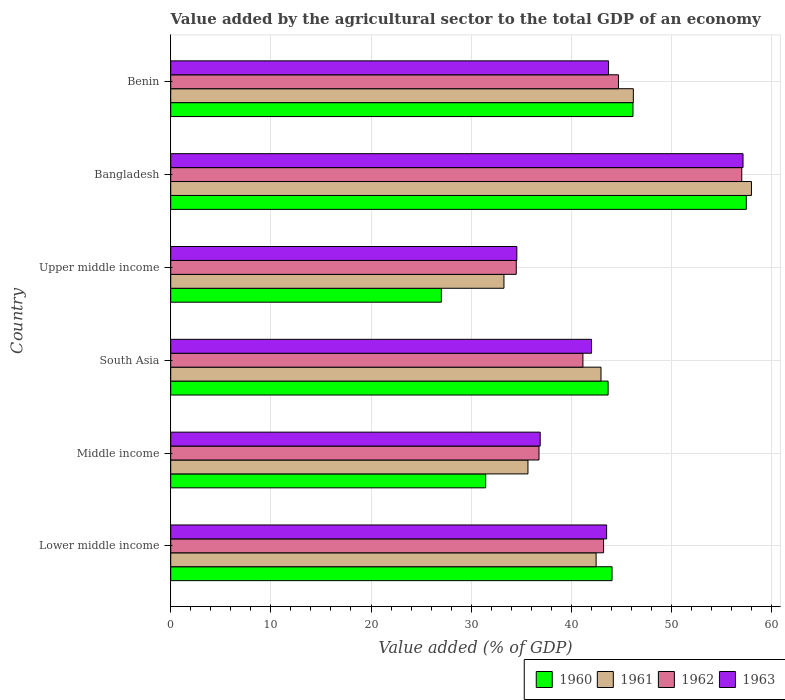How many different coloured bars are there?
Provide a short and direct response. 4. Are the number of bars per tick equal to the number of legend labels?
Ensure brevity in your answer.  Yes. How many bars are there on the 1st tick from the top?
Give a very brief answer. 4. How many bars are there on the 5th tick from the bottom?
Ensure brevity in your answer.  4. What is the label of the 3rd group of bars from the top?
Your answer should be very brief. Upper middle income. What is the value added by the agricultural sector to the total GDP in 1961 in Upper middle income?
Ensure brevity in your answer.  33.27. Across all countries, what is the maximum value added by the agricultural sector to the total GDP in 1960?
Offer a terse response. 57.47. Across all countries, what is the minimum value added by the agricultural sector to the total GDP in 1960?
Provide a short and direct response. 27.02. In which country was the value added by the agricultural sector to the total GDP in 1961 minimum?
Provide a short and direct response. Upper middle income. What is the total value added by the agricultural sector to the total GDP in 1960 in the graph?
Give a very brief answer. 249.85. What is the difference between the value added by the agricultural sector to the total GDP in 1961 in South Asia and that in Upper middle income?
Make the answer very short. 9.69. What is the difference between the value added by the agricultural sector to the total GDP in 1963 in Middle income and the value added by the agricultural sector to the total GDP in 1962 in Upper middle income?
Your answer should be very brief. 2.39. What is the average value added by the agricultural sector to the total GDP in 1963 per country?
Offer a terse response. 42.98. What is the difference between the value added by the agricultural sector to the total GDP in 1960 and value added by the agricultural sector to the total GDP in 1961 in Lower middle income?
Ensure brevity in your answer.  1.59. In how many countries, is the value added by the agricultural sector to the total GDP in 1962 greater than 58 %?
Make the answer very short. 0. What is the ratio of the value added by the agricultural sector to the total GDP in 1961 in South Asia to that in Upper middle income?
Give a very brief answer. 1.29. Is the value added by the agricultural sector to the total GDP in 1963 in Lower middle income less than that in Middle income?
Keep it short and to the point. No. Is the difference between the value added by the agricultural sector to the total GDP in 1960 in Lower middle income and Middle income greater than the difference between the value added by the agricultural sector to the total GDP in 1961 in Lower middle income and Middle income?
Your answer should be compact. Yes. What is the difference between the highest and the second highest value added by the agricultural sector to the total GDP in 1960?
Make the answer very short. 11.32. What is the difference between the highest and the lowest value added by the agricultural sector to the total GDP in 1960?
Your answer should be very brief. 30.45. In how many countries, is the value added by the agricultural sector to the total GDP in 1963 greater than the average value added by the agricultural sector to the total GDP in 1963 taken over all countries?
Provide a succinct answer. 3. Is the sum of the value added by the agricultural sector to the total GDP in 1960 in Bangladesh and Middle income greater than the maximum value added by the agricultural sector to the total GDP in 1962 across all countries?
Your answer should be compact. Yes. Is it the case that in every country, the sum of the value added by the agricultural sector to the total GDP in 1961 and value added by the agricultural sector to the total GDP in 1962 is greater than the sum of value added by the agricultural sector to the total GDP in 1963 and value added by the agricultural sector to the total GDP in 1960?
Make the answer very short. No. How many bars are there?
Your response must be concise. 24. Are all the bars in the graph horizontal?
Offer a terse response. Yes. Are the values on the major ticks of X-axis written in scientific E-notation?
Ensure brevity in your answer.  No. How many legend labels are there?
Give a very brief answer. 4. How are the legend labels stacked?
Offer a very short reply. Horizontal. What is the title of the graph?
Your answer should be compact. Value added by the agricultural sector to the total GDP of an economy. Does "1975" appear as one of the legend labels in the graph?
Provide a succinct answer. No. What is the label or title of the X-axis?
Give a very brief answer. Value added (% of GDP). What is the Value added (% of GDP) in 1960 in Lower middle income?
Your answer should be compact. 44.07. What is the Value added (% of GDP) of 1961 in Lower middle income?
Keep it short and to the point. 42.48. What is the Value added (% of GDP) in 1962 in Lower middle income?
Provide a short and direct response. 43.22. What is the Value added (% of GDP) in 1963 in Lower middle income?
Keep it short and to the point. 43.53. What is the Value added (% of GDP) of 1960 in Middle income?
Keep it short and to the point. 31.45. What is the Value added (% of GDP) in 1961 in Middle income?
Your answer should be compact. 35.67. What is the Value added (% of GDP) in 1962 in Middle income?
Provide a succinct answer. 36.77. What is the Value added (% of GDP) of 1963 in Middle income?
Your answer should be compact. 36.89. What is the Value added (% of GDP) of 1960 in South Asia?
Ensure brevity in your answer.  43.68. What is the Value added (% of GDP) in 1961 in South Asia?
Give a very brief answer. 42.96. What is the Value added (% of GDP) of 1962 in South Asia?
Your response must be concise. 41.16. What is the Value added (% of GDP) of 1963 in South Asia?
Your answer should be very brief. 42.02. What is the Value added (% of GDP) in 1960 in Upper middle income?
Your answer should be compact. 27.02. What is the Value added (% of GDP) of 1961 in Upper middle income?
Ensure brevity in your answer.  33.27. What is the Value added (% of GDP) of 1962 in Upper middle income?
Offer a very short reply. 34.5. What is the Value added (% of GDP) of 1963 in Upper middle income?
Offer a terse response. 34.56. What is the Value added (% of GDP) of 1960 in Bangladesh?
Offer a terse response. 57.47. What is the Value added (% of GDP) in 1961 in Bangladesh?
Provide a succinct answer. 57.99. What is the Value added (% of GDP) in 1962 in Bangladesh?
Keep it short and to the point. 57.02. What is the Value added (% of GDP) in 1963 in Bangladesh?
Keep it short and to the point. 57.15. What is the Value added (% of GDP) in 1960 in Benin?
Make the answer very short. 46.16. What is the Value added (% of GDP) of 1961 in Benin?
Provide a succinct answer. 46.19. What is the Value added (% of GDP) of 1962 in Benin?
Provide a short and direct response. 44.71. What is the Value added (% of GDP) in 1963 in Benin?
Keep it short and to the point. 43.72. Across all countries, what is the maximum Value added (% of GDP) in 1960?
Give a very brief answer. 57.47. Across all countries, what is the maximum Value added (% of GDP) in 1961?
Provide a succinct answer. 57.99. Across all countries, what is the maximum Value added (% of GDP) of 1962?
Keep it short and to the point. 57.02. Across all countries, what is the maximum Value added (% of GDP) in 1963?
Offer a very short reply. 57.15. Across all countries, what is the minimum Value added (% of GDP) of 1960?
Give a very brief answer. 27.02. Across all countries, what is the minimum Value added (% of GDP) in 1961?
Offer a terse response. 33.27. Across all countries, what is the minimum Value added (% of GDP) of 1962?
Provide a succinct answer. 34.5. Across all countries, what is the minimum Value added (% of GDP) in 1963?
Make the answer very short. 34.56. What is the total Value added (% of GDP) in 1960 in the graph?
Give a very brief answer. 249.85. What is the total Value added (% of GDP) in 1961 in the graph?
Make the answer very short. 258.57. What is the total Value added (% of GDP) of 1962 in the graph?
Ensure brevity in your answer.  257.39. What is the total Value added (% of GDP) in 1963 in the graph?
Offer a very short reply. 257.87. What is the difference between the Value added (% of GDP) in 1960 in Lower middle income and that in Middle income?
Provide a succinct answer. 12.62. What is the difference between the Value added (% of GDP) in 1961 in Lower middle income and that in Middle income?
Provide a short and direct response. 6.81. What is the difference between the Value added (% of GDP) in 1962 in Lower middle income and that in Middle income?
Offer a terse response. 6.45. What is the difference between the Value added (% of GDP) in 1963 in Lower middle income and that in Middle income?
Provide a short and direct response. 6.63. What is the difference between the Value added (% of GDP) in 1960 in Lower middle income and that in South Asia?
Offer a terse response. 0.39. What is the difference between the Value added (% of GDP) of 1961 in Lower middle income and that in South Asia?
Keep it short and to the point. -0.49. What is the difference between the Value added (% of GDP) of 1962 in Lower middle income and that in South Asia?
Offer a very short reply. 2.06. What is the difference between the Value added (% of GDP) of 1963 in Lower middle income and that in South Asia?
Give a very brief answer. 1.51. What is the difference between the Value added (% of GDP) in 1960 in Lower middle income and that in Upper middle income?
Your answer should be very brief. 17.05. What is the difference between the Value added (% of GDP) in 1961 in Lower middle income and that in Upper middle income?
Provide a short and direct response. 9.2. What is the difference between the Value added (% of GDP) of 1962 in Lower middle income and that in Upper middle income?
Ensure brevity in your answer.  8.72. What is the difference between the Value added (% of GDP) of 1963 in Lower middle income and that in Upper middle income?
Your response must be concise. 8.97. What is the difference between the Value added (% of GDP) in 1960 in Lower middle income and that in Bangladesh?
Your answer should be compact. -13.41. What is the difference between the Value added (% of GDP) of 1961 in Lower middle income and that in Bangladesh?
Ensure brevity in your answer.  -15.51. What is the difference between the Value added (% of GDP) in 1962 in Lower middle income and that in Bangladesh?
Provide a succinct answer. -13.8. What is the difference between the Value added (% of GDP) in 1963 in Lower middle income and that in Bangladesh?
Ensure brevity in your answer.  -13.62. What is the difference between the Value added (% of GDP) of 1960 in Lower middle income and that in Benin?
Your response must be concise. -2.09. What is the difference between the Value added (% of GDP) in 1961 in Lower middle income and that in Benin?
Give a very brief answer. -3.72. What is the difference between the Value added (% of GDP) of 1962 in Lower middle income and that in Benin?
Your answer should be very brief. -1.49. What is the difference between the Value added (% of GDP) of 1963 in Lower middle income and that in Benin?
Offer a terse response. -0.19. What is the difference between the Value added (% of GDP) of 1960 in Middle income and that in South Asia?
Offer a very short reply. -12.22. What is the difference between the Value added (% of GDP) of 1961 in Middle income and that in South Asia?
Your response must be concise. -7.29. What is the difference between the Value added (% of GDP) in 1962 in Middle income and that in South Asia?
Provide a succinct answer. -4.39. What is the difference between the Value added (% of GDP) of 1963 in Middle income and that in South Asia?
Provide a short and direct response. -5.13. What is the difference between the Value added (% of GDP) in 1960 in Middle income and that in Upper middle income?
Your response must be concise. 4.43. What is the difference between the Value added (% of GDP) of 1961 in Middle income and that in Upper middle income?
Your answer should be compact. 2.4. What is the difference between the Value added (% of GDP) in 1962 in Middle income and that in Upper middle income?
Make the answer very short. 2.27. What is the difference between the Value added (% of GDP) of 1963 in Middle income and that in Upper middle income?
Your answer should be very brief. 2.33. What is the difference between the Value added (% of GDP) of 1960 in Middle income and that in Bangladesh?
Offer a very short reply. -26.02. What is the difference between the Value added (% of GDP) of 1961 in Middle income and that in Bangladesh?
Your response must be concise. -22.32. What is the difference between the Value added (% of GDP) of 1962 in Middle income and that in Bangladesh?
Your answer should be compact. -20.24. What is the difference between the Value added (% of GDP) of 1963 in Middle income and that in Bangladesh?
Your response must be concise. -20.25. What is the difference between the Value added (% of GDP) of 1960 in Middle income and that in Benin?
Your answer should be compact. -14.71. What is the difference between the Value added (% of GDP) in 1961 in Middle income and that in Benin?
Your response must be concise. -10.52. What is the difference between the Value added (% of GDP) in 1962 in Middle income and that in Benin?
Make the answer very short. -7.94. What is the difference between the Value added (% of GDP) of 1963 in Middle income and that in Benin?
Make the answer very short. -6.82. What is the difference between the Value added (% of GDP) in 1960 in South Asia and that in Upper middle income?
Offer a very short reply. 16.65. What is the difference between the Value added (% of GDP) in 1961 in South Asia and that in Upper middle income?
Offer a terse response. 9.69. What is the difference between the Value added (% of GDP) of 1962 in South Asia and that in Upper middle income?
Make the answer very short. 6.66. What is the difference between the Value added (% of GDP) in 1963 in South Asia and that in Upper middle income?
Your response must be concise. 7.46. What is the difference between the Value added (% of GDP) in 1960 in South Asia and that in Bangladesh?
Ensure brevity in your answer.  -13.8. What is the difference between the Value added (% of GDP) of 1961 in South Asia and that in Bangladesh?
Make the answer very short. -15.02. What is the difference between the Value added (% of GDP) of 1962 in South Asia and that in Bangladesh?
Offer a very short reply. -15.86. What is the difference between the Value added (% of GDP) of 1963 in South Asia and that in Bangladesh?
Offer a terse response. -15.13. What is the difference between the Value added (% of GDP) in 1960 in South Asia and that in Benin?
Make the answer very short. -2.48. What is the difference between the Value added (% of GDP) in 1961 in South Asia and that in Benin?
Offer a terse response. -3.23. What is the difference between the Value added (% of GDP) in 1962 in South Asia and that in Benin?
Provide a succinct answer. -3.55. What is the difference between the Value added (% of GDP) of 1963 in South Asia and that in Benin?
Your answer should be very brief. -1.7. What is the difference between the Value added (% of GDP) in 1960 in Upper middle income and that in Bangladesh?
Provide a succinct answer. -30.45. What is the difference between the Value added (% of GDP) of 1961 in Upper middle income and that in Bangladesh?
Offer a terse response. -24.71. What is the difference between the Value added (% of GDP) of 1962 in Upper middle income and that in Bangladesh?
Keep it short and to the point. -22.51. What is the difference between the Value added (% of GDP) in 1963 in Upper middle income and that in Bangladesh?
Ensure brevity in your answer.  -22.59. What is the difference between the Value added (% of GDP) in 1960 in Upper middle income and that in Benin?
Offer a very short reply. -19.14. What is the difference between the Value added (% of GDP) in 1961 in Upper middle income and that in Benin?
Keep it short and to the point. -12.92. What is the difference between the Value added (% of GDP) in 1962 in Upper middle income and that in Benin?
Offer a very short reply. -10.21. What is the difference between the Value added (% of GDP) in 1963 in Upper middle income and that in Benin?
Ensure brevity in your answer.  -9.16. What is the difference between the Value added (% of GDP) in 1960 in Bangladesh and that in Benin?
Keep it short and to the point. 11.32. What is the difference between the Value added (% of GDP) of 1961 in Bangladesh and that in Benin?
Your answer should be very brief. 11.79. What is the difference between the Value added (% of GDP) in 1962 in Bangladesh and that in Benin?
Provide a short and direct response. 12.31. What is the difference between the Value added (% of GDP) of 1963 in Bangladesh and that in Benin?
Provide a succinct answer. 13.43. What is the difference between the Value added (% of GDP) in 1960 in Lower middle income and the Value added (% of GDP) in 1961 in Middle income?
Your answer should be compact. 8.4. What is the difference between the Value added (% of GDP) of 1960 in Lower middle income and the Value added (% of GDP) of 1962 in Middle income?
Offer a terse response. 7.29. What is the difference between the Value added (% of GDP) of 1960 in Lower middle income and the Value added (% of GDP) of 1963 in Middle income?
Provide a succinct answer. 7.17. What is the difference between the Value added (% of GDP) of 1961 in Lower middle income and the Value added (% of GDP) of 1962 in Middle income?
Your answer should be very brief. 5.7. What is the difference between the Value added (% of GDP) of 1961 in Lower middle income and the Value added (% of GDP) of 1963 in Middle income?
Make the answer very short. 5.58. What is the difference between the Value added (% of GDP) of 1962 in Lower middle income and the Value added (% of GDP) of 1963 in Middle income?
Your answer should be very brief. 6.33. What is the difference between the Value added (% of GDP) of 1960 in Lower middle income and the Value added (% of GDP) of 1961 in South Asia?
Ensure brevity in your answer.  1.1. What is the difference between the Value added (% of GDP) in 1960 in Lower middle income and the Value added (% of GDP) in 1962 in South Asia?
Make the answer very short. 2.91. What is the difference between the Value added (% of GDP) in 1960 in Lower middle income and the Value added (% of GDP) in 1963 in South Asia?
Ensure brevity in your answer.  2.05. What is the difference between the Value added (% of GDP) in 1961 in Lower middle income and the Value added (% of GDP) in 1962 in South Asia?
Provide a short and direct response. 1.32. What is the difference between the Value added (% of GDP) of 1961 in Lower middle income and the Value added (% of GDP) of 1963 in South Asia?
Give a very brief answer. 0.46. What is the difference between the Value added (% of GDP) in 1962 in Lower middle income and the Value added (% of GDP) in 1963 in South Asia?
Your response must be concise. 1.2. What is the difference between the Value added (% of GDP) in 1960 in Lower middle income and the Value added (% of GDP) in 1961 in Upper middle income?
Your answer should be very brief. 10.79. What is the difference between the Value added (% of GDP) of 1960 in Lower middle income and the Value added (% of GDP) of 1962 in Upper middle income?
Your answer should be very brief. 9.56. What is the difference between the Value added (% of GDP) of 1960 in Lower middle income and the Value added (% of GDP) of 1963 in Upper middle income?
Make the answer very short. 9.51. What is the difference between the Value added (% of GDP) in 1961 in Lower middle income and the Value added (% of GDP) in 1962 in Upper middle income?
Your response must be concise. 7.97. What is the difference between the Value added (% of GDP) of 1961 in Lower middle income and the Value added (% of GDP) of 1963 in Upper middle income?
Your response must be concise. 7.92. What is the difference between the Value added (% of GDP) of 1962 in Lower middle income and the Value added (% of GDP) of 1963 in Upper middle income?
Ensure brevity in your answer.  8.66. What is the difference between the Value added (% of GDP) of 1960 in Lower middle income and the Value added (% of GDP) of 1961 in Bangladesh?
Provide a short and direct response. -13.92. What is the difference between the Value added (% of GDP) in 1960 in Lower middle income and the Value added (% of GDP) in 1962 in Bangladesh?
Your response must be concise. -12.95. What is the difference between the Value added (% of GDP) of 1960 in Lower middle income and the Value added (% of GDP) of 1963 in Bangladesh?
Your answer should be very brief. -13.08. What is the difference between the Value added (% of GDP) in 1961 in Lower middle income and the Value added (% of GDP) in 1962 in Bangladesh?
Ensure brevity in your answer.  -14.54. What is the difference between the Value added (% of GDP) of 1961 in Lower middle income and the Value added (% of GDP) of 1963 in Bangladesh?
Your answer should be compact. -14.67. What is the difference between the Value added (% of GDP) in 1962 in Lower middle income and the Value added (% of GDP) in 1963 in Bangladesh?
Your response must be concise. -13.93. What is the difference between the Value added (% of GDP) in 1960 in Lower middle income and the Value added (% of GDP) in 1961 in Benin?
Your answer should be very brief. -2.13. What is the difference between the Value added (% of GDP) in 1960 in Lower middle income and the Value added (% of GDP) in 1962 in Benin?
Keep it short and to the point. -0.64. What is the difference between the Value added (% of GDP) in 1960 in Lower middle income and the Value added (% of GDP) in 1963 in Benin?
Your response must be concise. 0.35. What is the difference between the Value added (% of GDP) of 1961 in Lower middle income and the Value added (% of GDP) of 1962 in Benin?
Ensure brevity in your answer.  -2.23. What is the difference between the Value added (% of GDP) of 1961 in Lower middle income and the Value added (% of GDP) of 1963 in Benin?
Make the answer very short. -1.24. What is the difference between the Value added (% of GDP) in 1962 in Lower middle income and the Value added (% of GDP) in 1963 in Benin?
Your answer should be compact. -0.5. What is the difference between the Value added (% of GDP) of 1960 in Middle income and the Value added (% of GDP) of 1961 in South Asia?
Keep it short and to the point. -11.51. What is the difference between the Value added (% of GDP) of 1960 in Middle income and the Value added (% of GDP) of 1962 in South Asia?
Provide a succinct answer. -9.71. What is the difference between the Value added (% of GDP) in 1960 in Middle income and the Value added (% of GDP) in 1963 in South Asia?
Offer a terse response. -10.57. What is the difference between the Value added (% of GDP) in 1961 in Middle income and the Value added (% of GDP) in 1962 in South Asia?
Offer a terse response. -5.49. What is the difference between the Value added (% of GDP) of 1961 in Middle income and the Value added (% of GDP) of 1963 in South Asia?
Give a very brief answer. -6.35. What is the difference between the Value added (% of GDP) in 1962 in Middle income and the Value added (% of GDP) in 1963 in South Asia?
Provide a succinct answer. -5.25. What is the difference between the Value added (% of GDP) of 1960 in Middle income and the Value added (% of GDP) of 1961 in Upper middle income?
Give a very brief answer. -1.82. What is the difference between the Value added (% of GDP) in 1960 in Middle income and the Value added (% of GDP) in 1962 in Upper middle income?
Give a very brief answer. -3.05. What is the difference between the Value added (% of GDP) of 1960 in Middle income and the Value added (% of GDP) of 1963 in Upper middle income?
Ensure brevity in your answer.  -3.11. What is the difference between the Value added (% of GDP) in 1961 in Middle income and the Value added (% of GDP) in 1962 in Upper middle income?
Give a very brief answer. 1.17. What is the difference between the Value added (% of GDP) in 1961 in Middle income and the Value added (% of GDP) in 1963 in Upper middle income?
Provide a short and direct response. 1.11. What is the difference between the Value added (% of GDP) of 1962 in Middle income and the Value added (% of GDP) of 1963 in Upper middle income?
Ensure brevity in your answer.  2.21. What is the difference between the Value added (% of GDP) of 1960 in Middle income and the Value added (% of GDP) of 1961 in Bangladesh?
Ensure brevity in your answer.  -26.54. What is the difference between the Value added (% of GDP) in 1960 in Middle income and the Value added (% of GDP) in 1962 in Bangladesh?
Your response must be concise. -25.57. What is the difference between the Value added (% of GDP) in 1960 in Middle income and the Value added (% of GDP) in 1963 in Bangladesh?
Make the answer very short. -25.7. What is the difference between the Value added (% of GDP) of 1961 in Middle income and the Value added (% of GDP) of 1962 in Bangladesh?
Provide a short and direct response. -21.35. What is the difference between the Value added (% of GDP) in 1961 in Middle income and the Value added (% of GDP) in 1963 in Bangladesh?
Offer a terse response. -21.48. What is the difference between the Value added (% of GDP) of 1962 in Middle income and the Value added (% of GDP) of 1963 in Bangladesh?
Your response must be concise. -20.37. What is the difference between the Value added (% of GDP) in 1960 in Middle income and the Value added (% of GDP) in 1961 in Benin?
Provide a succinct answer. -14.74. What is the difference between the Value added (% of GDP) in 1960 in Middle income and the Value added (% of GDP) in 1962 in Benin?
Your answer should be very brief. -13.26. What is the difference between the Value added (% of GDP) of 1960 in Middle income and the Value added (% of GDP) of 1963 in Benin?
Keep it short and to the point. -12.27. What is the difference between the Value added (% of GDP) of 1961 in Middle income and the Value added (% of GDP) of 1962 in Benin?
Give a very brief answer. -9.04. What is the difference between the Value added (% of GDP) in 1961 in Middle income and the Value added (% of GDP) in 1963 in Benin?
Provide a succinct answer. -8.05. What is the difference between the Value added (% of GDP) of 1962 in Middle income and the Value added (% of GDP) of 1963 in Benin?
Keep it short and to the point. -6.94. What is the difference between the Value added (% of GDP) of 1960 in South Asia and the Value added (% of GDP) of 1961 in Upper middle income?
Keep it short and to the point. 10.4. What is the difference between the Value added (% of GDP) in 1960 in South Asia and the Value added (% of GDP) in 1962 in Upper middle income?
Provide a succinct answer. 9.17. What is the difference between the Value added (% of GDP) of 1960 in South Asia and the Value added (% of GDP) of 1963 in Upper middle income?
Your response must be concise. 9.11. What is the difference between the Value added (% of GDP) in 1961 in South Asia and the Value added (% of GDP) in 1962 in Upper middle income?
Your response must be concise. 8.46. What is the difference between the Value added (% of GDP) of 1961 in South Asia and the Value added (% of GDP) of 1963 in Upper middle income?
Give a very brief answer. 8.4. What is the difference between the Value added (% of GDP) of 1962 in South Asia and the Value added (% of GDP) of 1963 in Upper middle income?
Provide a short and direct response. 6.6. What is the difference between the Value added (% of GDP) of 1960 in South Asia and the Value added (% of GDP) of 1961 in Bangladesh?
Keep it short and to the point. -14.31. What is the difference between the Value added (% of GDP) in 1960 in South Asia and the Value added (% of GDP) in 1962 in Bangladesh?
Your answer should be very brief. -13.34. What is the difference between the Value added (% of GDP) of 1960 in South Asia and the Value added (% of GDP) of 1963 in Bangladesh?
Keep it short and to the point. -13.47. What is the difference between the Value added (% of GDP) in 1961 in South Asia and the Value added (% of GDP) in 1962 in Bangladesh?
Make the answer very short. -14.05. What is the difference between the Value added (% of GDP) of 1961 in South Asia and the Value added (% of GDP) of 1963 in Bangladesh?
Your answer should be very brief. -14.18. What is the difference between the Value added (% of GDP) of 1962 in South Asia and the Value added (% of GDP) of 1963 in Bangladesh?
Offer a very short reply. -15.99. What is the difference between the Value added (% of GDP) in 1960 in South Asia and the Value added (% of GDP) in 1961 in Benin?
Your answer should be very brief. -2.52. What is the difference between the Value added (% of GDP) of 1960 in South Asia and the Value added (% of GDP) of 1962 in Benin?
Keep it short and to the point. -1.03. What is the difference between the Value added (% of GDP) of 1960 in South Asia and the Value added (% of GDP) of 1963 in Benin?
Your answer should be very brief. -0.04. What is the difference between the Value added (% of GDP) of 1961 in South Asia and the Value added (% of GDP) of 1962 in Benin?
Your answer should be compact. -1.74. What is the difference between the Value added (% of GDP) of 1961 in South Asia and the Value added (% of GDP) of 1963 in Benin?
Provide a succinct answer. -0.75. What is the difference between the Value added (% of GDP) of 1962 in South Asia and the Value added (% of GDP) of 1963 in Benin?
Your answer should be very brief. -2.56. What is the difference between the Value added (% of GDP) of 1960 in Upper middle income and the Value added (% of GDP) of 1961 in Bangladesh?
Give a very brief answer. -30.97. What is the difference between the Value added (% of GDP) in 1960 in Upper middle income and the Value added (% of GDP) in 1962 in Bangladesh?
Your answer should be very brief. -30. What is the difference between the Value added (% of GDP) of 1960 in Upper middle income and the Value added (% of GDP) of 1963 in Bangladesh?
Provide a succinct answer. -30.12. What is the difference between the Value added (% of GDP) in 1961 in Upper middle income and the Value added (% of GDP) in 1962 in Bangladesh?
Give a very brief answer. -23.74. What is the difference between the Value added (% of GDP) in 1961 in Upper middle income and the Value added (% of GDP) in 1963 in Bangladesh?
Keep it short and to the point. -23.87. What is the difference between the Value added (% of GDP) of 1962 in Upper middle income and the Value added (% of GDP) of 1963 in Bangladesh?
Offer a very short reply. -22.64. What is the difference between the Value added (% of GDP) of 1960 in Upper middle income and the Value added (% of GDP) of 1961 in Benin?
Give a very brief answer. -19.17. What is the difference between the Value added (% of GDP) of 1960 in Upper middle income and the Value added (% of GDP) of 1962 in Benin?
Give a very brief answer. -17.69. What is the difference between the Value added (% of GDP) in 1960 in Upper middle income and the Value added (% of GDP) in 1963 in Benin?
Give a very brief answer. -16.7. What is the difference between the Value added (% of GDP) of 1961 in Upper middle income and the Value added (% of GDP) of 1962 in Benin?
Provide a succinct answer. -11.43. What is the difference between the Value added (% of GDP) in 1961 in Upper middle income and the Value added (% of GDP) in 1963 in Benin?
Provide a succinct answer. -10.44. What is the difference between the Value added (% of GDP) in 1962 in Upper middle income and the Value added (% of GDP) in 1963 in Benin?
Your answer should be compact. -9.21. What is the difference between the Value added (% of GDP) in 1960 in Bangladesh and the Value added (% of GDP) in 1961 in Benin?
Offer a very short reply. 11.28. What is the difference between the Value added (% of GDP) of 1960 in Bangladesh and the Value added (% of GDP) of 1962 in Benin?
Make the answer very short. 12.77. What is the difference between the Value added (% of GDP) of 1960 in Bangladesh and the Value added (% of GDP) of 1963 in Benin?
Make the answer very short. 13.76. What is the difference between the Value added (% of GDP) in 1961 in Bangladesh and the Value added (% of GDP) in 1962 in Benin?
Provide a short and direct response. 13.28. What is the difference between the Value added (% of GDP) of 1961 in Bangladesh and the Value added (% of GDP) of 1963 in Benin?
Your answer should be compact. 14.27. What is the difference between the Value added (% of GDP) of 1962 in Bangladesh and the Value added (% of GDP) of 1963 in Benin?
Your answer should be compact. 13.3. What is the average Value added (% of GDP) of 1960 per country?
Your answer should be very brief. 41.64. What is the average Value added (% of GDP) of 1961 per country?
Keep it short and to the point. 43.09. What is the average Value added (% of GDP) of 1962 per country?
Ensure brevity in your answer.  42.9. What is the average Value added (% of GDP) in 1963 per country?
Provide a succinct answer. 42.98. What is the difference between the Value added (% of GDP) in 1960 and Value added (% of GDP) in 1961 in Lower middle income?
Offer a terse response. 1.59. What is the difference between the Value added (% of GDP) in 1960 and Value added (% of GDP) in 1962 in Lower middle income?
Provide a short and direct response. 0.85. What is the difference between the Value added (% of GDP) in 1960 and Value added (% of GDP) in 1963 in Lower middle income?
Your answer should be very brief. 0.54. What is the difference between the Value added (% of GDP) of 1961 and Value added (% of GDP) of 1962 in Lower middle income?
Provide a succinct answer. -0.75. What is the difference between the Value added (% of GDP) in 1961 and Value added (% of GDP) in 1963 in Lower middle income?
Keep it short and to the point. -1.05. What is the difference between the Value added (% of GDP) of 1962 and Value added (% of GDP) of 1963 in Lower middle income?
Offer a very short reply. -0.3. What is the difference between the Value added (% of GDP) of 1960 and Value added (% of GDP) of 1961 in Middle income?
Provide a short and direct response. -4.22. What is the difference between the Value added (% of GDP) of 1960 and Value added (% of GDP) of 1962 in Middle income?
Make the answer very short. -5.32. What is the difference between the Value added (% of GDP) of 1960 and Value added (% of GDP) of 1963 in Middle income?
Make the answer very short. -5.44. What is the difference between the Value added (% of GDP) in 1961 and Value added (% of GDP) in 1962 in Middle income?
Ensure brevity in your answer.  -1.1. What is the difference between the Value added (% of GDP) of 1961 and Value added (% of GDP) of 1963 in Middle income?
Provide a short and direct response. -1.22. What is the difference between the Value added (% of GDP) of 1962 and Value added (% of GDP) of 1963 in Middle income?
Your answer should be compact. -0.12. What is the difference between the Value added (% of GDP) of 1960 and Value added (% of GDP) of 1961 in South Asia?
Give a very brief answer. 0.71. What is the difference between the Value added (% of GDP) in 1960 and Value added (% of GDP) in 1962 in South Asia?
Your answer should be compact. 2.52. What is the difference between the Value added (% of GDP) in 1960 and Value added (% of GDP) in 1963 in South Asia?
Keep it short and to the point. 1.66. What is the difference between the Value added (% of GDP) in 1961 and Value added (% of GDP) in 1962 in South Asia?
Your answer should be very brief. 1.8. What is the difference between the Value added (% of GDP) of 1961 and Value added (% of GDP) of 1963 in South Asia?
Make the answer very short. 0.95. What is the difference between the Value added (% of GDP) of 1962 and Value added (% of GDP) of 1963 in South Asia?
Your answer should be very brief. -0.86. What is the difference between the Value added (% of GDP) of 1960 and Value added (% of GDP) of 1961 in Upper middle income?
Ensure brevity in your answer.  -6.25. What is the difference between the Value added (% of GDP) of 1960 and Value added (% of GDP) of 1962 in Upper middle income?
Provide a succinct answer. -7.48. What is the difference between the Value added (% of GDP) in 1960 and Value added (% of GDP) in 1963 in Upper middle income?
Offer a terse response. -7.54. What is the difference between the Value added (% of GDP) of 1961 and Value added (% of GDP) of 1962 in Upper middle income?
Your answer should be compact. -1.23. What is the difference between the Value added (% of GDP) of 1961 and Value added (% of GDP) of 1963 in Upper middle income?
Give a very brief answer. -1.29. What is the difference between the Value added (% of GDP) in 1962 and Value added (% of GDP) in 1963 in Upper middle income?
Provide a short and direct response. -0.06. What is the difference between the Value added (% of GDP) in 1960 and Value added (% of GDP) in 1961 in Bangladesh?
Provide a succinct answer. -0.51. What is the difference between the Value added (% of GDP) of 1960 and Value added (% of GDP) of 1962 in Bangladesh?
Your answer should be very brief. 0.46. What is the difference between the Value added (% of GDP) of 1960 and Value added (% of GDP) of 1963 in Bangladesh?
Make the answer very short. 0.33. What is the difference between the Value added (% of GDP) of 1961 and Value added (% of GDP) of 1962 in Bangladesh?
Give a very brief answer. 0.97. What is the difference between the Value added (% of GDP) of 1961 and Value added (% of GDP) of 1963 in Bangladesh?
Provide a short and direct response. 0.84. What is the difference between the Value added (% of GDP) in 1962 and Value added (% of GDP) in 1963 in Bangladesh?
Give a very brief answer. -0.13. What is the difference between the Value added (% of GDP) in 1960 and Value added (% of GDP) in 1961 in Benin?
Provide a succinct answer. -0.04. What is the difference between the Value added (% of GDP) in 1960 and Value added (% of GDP) in 1962 in Benin?
Your response must be concise. 1.45. What is the difference between the Value added (% of GDP) of 1960 and Value added (% of GDP) of 1963 in Benin?
Your answer should be compact. 2.44. What is the difference between the Value added (% of GDP) of 1961 and Value added (% of GDP) of 1962 in Benin?
Your answer should be compact. 1.48. What is the difference between the Value added (% of GDP) in 1961 and Value added (% of GDP) in 1963 in Benin?
Provide a succinct answer. 2.48. What is the difference between the Value added (% of GDP) of 1962 and Value added (% of GDP) of 1963 in Benin?
Ensure brevity in your answer.  0.99. What is the ratio of the Value added (% of GDP) in 1960 in Lower middle income to that in Middle income?
Provide a short and direct response. 1.4. What is the ratio of the Value added (% of GDP) in 1961 in Lower middle income to that in Middle income?
Provide a succinct answer. 1.19. What is the ratio of the Value added (% of GDP) in 1962 in Lower middle income to that in Middle income?
Your response must be concise. 1.18. What is the ratio of the Value added (% of GDP) of 1963 in Lower middle income to that in Middle income?
Make the answer very short. 1.18. What is the ratio of the Value added (% of GDP) in 1961 in Lower middle income to that in South Asia?
Ensure brevity in your answer.  0.99. What is the ratio of the Value added (% of GDP) of 1962 in Lower middle income to that in South Asia?
Offer a very short reply. 1.05. What is the ratio of the Value added (% of GDP) of 1963 in Lower middle income to that in South Asia?
Offer a terse response. 1.04. What is the ratio of the Value added (% of GDP) in 1960 in Lower middle income to that in Upper middle income?
Provide a succinct answer. 1.63. What is the ratio of the Value added (% of GDP) in 1961 in Lower middle income to that in Upper middle income?
Your answer should be compact. 1.28. What is the ratio of the Value added (% of GDP) in 1962 in Lower middle income to that in Upper middle income?
Offer a very short reply. 1.25. What is the ratio of the Value added (% of GDP) in 1963 in Lower middle income to that in Upper middle income?
Make the answer very short. 1.26. What is the ratio of the Value added (% of GDP) in 1960 in Lower middle income to that in Bangladesh?
Ensure brevity in your answer.  0.77. What is the ratio of the Value added (% of GDP) of 1961 in Lower middle income to that in Bangladesh?
Keep it short and to the point. 0.73. What is the ratio of the Value added (% of GDP) in 1962 in Lower middle income to that in Bangladesh?
Ensure brevity in your answer.  0.76. What is the ratio of the Value added (% of GDP) in 1963 in Lower middle income to that in Bangladesh?
Offer a very short reply. 0.76. What is the ratio of the Value added (% of GDP) of 1960 in Lower middle income to that in Benin?
Your answer should be compact. 0.95. What is the ratio of the Value added (% of GDP) of 1961 in Lower middle income to that in Benin?
Offer a very short reply. 0.92. What is the ratio of the Value added (% of GDP) in 1962 in Lower middle income to that in Benin?
Keep it short and to the point. 0.97. What is the ratio of the Value added (% of GDP) in 1960 in Middle income to that in South Asia?
Your answer should be compact. 0.72. What is the ratio of the Value added (% of GDP) in 1961 in Middle income to that in South Asia?
Offer a terse response. 0.83. What is the ratio of the Value added (% of GDP) in 1962 in Middle income to that in South Asia?
Provide a short and direct response. 0.89. What is the ratio of the Value added (% of GDP) of 1963 in Middle income to that in South Asia?
Your answer should be very brief. 0.88. What is the ratio of the Value added (% of GDP) in 1960 in Middle income to that in Upper middle income?
Provide a succinct answer. 1.16. What is the ratio of the Value added (% of GDP) of 1961 in Middle income to that in Upper middle income?
Ensure brevity in your answer.  1.07. What is the ratio of the Value added (% of GDP) in 1962 in Middle income to that in Upper middle income?
Make the answer very short. 1.07. What is the ratio of the Value added (% of GDP) of 1963 in Middle income to that in Upper middle income?
Your response must be concise. 1.07. What is the ratio of the Value added (% of GDP) of 1960 in Middle income to that in Bangladesh?
Your response must be concise. 0.55. What is the ratio of the Value added (% of GDP) in 1961 in Middle income to that in Bangladesh?
Give a very brief answer. 0.62. What is the ratio of the Value added (% of GDP) of 1962 in Middle income to that in Bangladesh?
Make the answer very short. 0.64. What is the ratio of the Value added (% of GDP) in 1963 in Middle income to that in Bangladesh?
Offer a very short reply. 0.65. What is the ratio of the Value added (% of GDP) in 1960 in Middle income to that in Benin?
Your answer should be compact. 0.68. What is the ratio of the Value added (% of GDP) in 1961 in Middle income to that in Benin?
Provide a short and direct response. 0.77. What is the ratio of the Value added (% of GDP) of 1962 in Middle income to that in Benin?
Keep it short and to the point. 0.82. What is the ratio of the Value added (% of GDP) of 1963 in Middle income to that in Benin?
Offer a terse response. 0.84. What is the ratio of the Value added (% of GDP) in 1960 in South Asia to that in Upper middle income?
Offer a terse response. 1.62. What is the ratio of the Value added (% of GDP) of 1961 in South Asia to that in Upper middle income?
Your response must be concise. 1.29. What is the ratio of the Value added (% of GDP) in 1962 in South Asia to that in Upper middle income?
Offer a very short reply. 1.19. What is the ratio of the Value added (% of GDP) of 1963 in South Asia to that in Upper middle income?
Your answer should be very brief. 1.22. What is the ratio of the Value added (% of GDP) of 1960 in South Asia to that in Bangladesh?
Ensure brevity in your answer.  0.76. What is the ratio of the Value added (% of GDP) of 1961 in South Asia to that in Bangladesh?
Provide a short and direct response. 0.74. What is the ratio of the Value added (% of GDP) in 1962 in South Asia to that in Bangladesh?
Your answer should be very brief. 0.72. What is the ratio of the Value added (% of GDP) in 1963 in South Asia to that in Bangladesh?
Provide a short and direct response. 0.74. What is the ratio of the Value added (% of GDP) in 1960 in South Asia to that in Benin?
Your answer should be very brief. 0.95. What is the ratio of the Value added (% of GDP) in 1961 in South Asia to that in Benin?
Provide a succinct answer. 0.93. What is the ratio of the Value added (% of GDP) in 1962 in South Asia to that in Benin?
Provide a short and direct response. 0.92. What is the ratio of the Value added (% of GDP) in 1963 in South Asia to that in Benin?
Keep it short and to the point. 0.96. What is the ratio of the Value added (% of GDP) in 1960 in Upper middle income to that in Bangladesh?
Offer a terse response. 0.47. What is the ratio of the Value added (% of GDP) in 1961 in Upper middle income to that in Bangladesh?
Provide a succinct answer. 0.57. What is the ratio of the Value added (% of GDP) of 1962 in Upper middle income to that in Bangladesh?
Give a very brief answer. 0.61. What is the ratio of the Value added (% of GDP) in 1963 in Upper middle income to that in Bangladesh?
Your answer should be compact. 0.6. What is the ratio of the Value added (% of GDP) of 1960 in Upper middle income to that in Benin?
Ensure brevity in your answer.  0.59. What is the ratio of the Value added (% of GDP) in 1961 in Upper middle income to that in Benin?
Your answer should be very brief. 0.72. What is the ratio of the Value added (% of GDP) of 1962 in Upper middle income to that in Benin?
Offer a terse response. 0.77. What is the ratio of the Value added (% of GDP) in 1963 in Upper middle income to that in Benin?
Give a very brief answer. 0.79. What is the ratio of the Value added (% of GDP) of 1960 in Bangladesh to that in Benin?
Your response must be concise. 1.25. What is the ratio of the Value added (% of GDP) of 1961 in Bangladesh to that in Benin?
Provide a short and direct response. 1.26. What is the ratio of the Value added (% of GDP) of 1962 in Bangladesh to that in Benin?
Provide a succinct answer. 1.28. What is the ratio of the Value added (% of GDP) of 1963 in Bangladesh to that in Benin?
Offer a very short reply. 1.31. What is the difference between the highest and the second highest Value added (% of GDP) in 1960?
Your answer should be very brief. 11.32. What is the difference between the highest and the second highest Value added (% of GDP) in 1961?
Make the answer very short. 11.79. What is the difference between the highest and the second highest Value added (% of GDP) of 1962?
Ensure brevity in your answer.  12.31. What is the difference between the highest and the second highest Value added (% of GDP) of 1963?
Your answer should be compact. 13.43. What is the difference between the highest and the lowest Value added (% of GDP) in 1960?
Keep it short and to the point. 30.45. What is the difference between the highest and the lowest Value added (% of GDP) in 1961?
Provide a short and direct response. 24.71. What is the difference between the highest and the lowest Value added (% of GDP) in 1962?
Provide a short and direct response. 22.51. What is the difference between the highest and the lowest Value added (% of GDP) in 1963?
Ensure brevity in your answer.  22.59. 